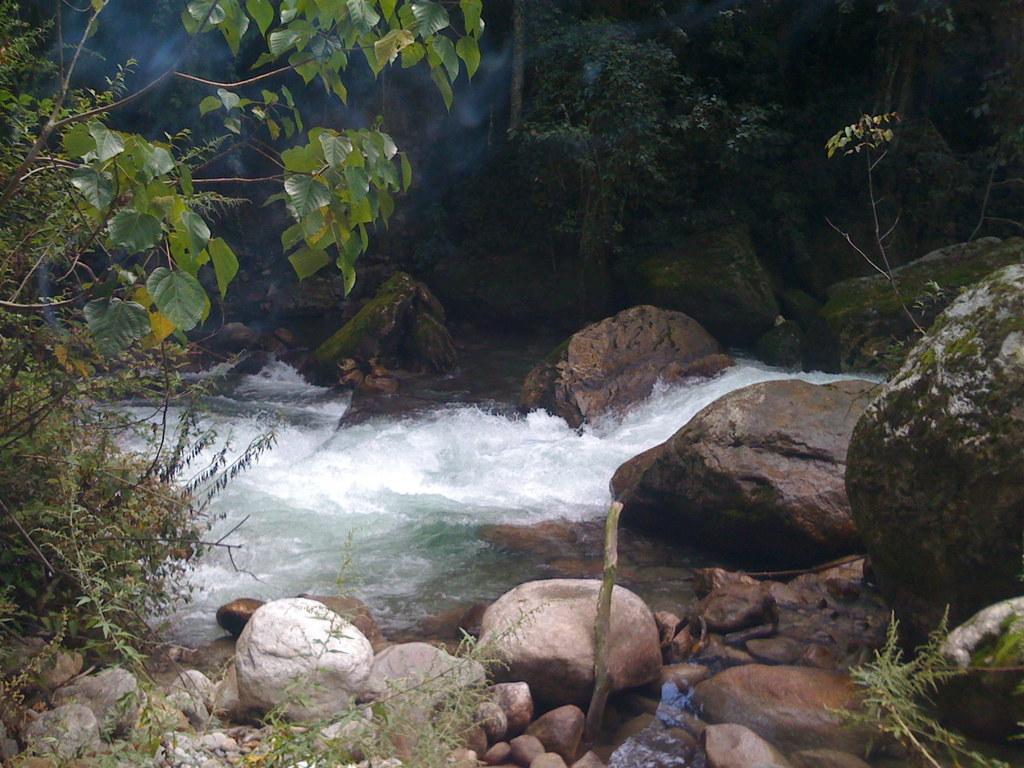Please provide a concise description of this image. In this image in front there are rocks. In the center of the image there is water. In the background of the image there are trees. 